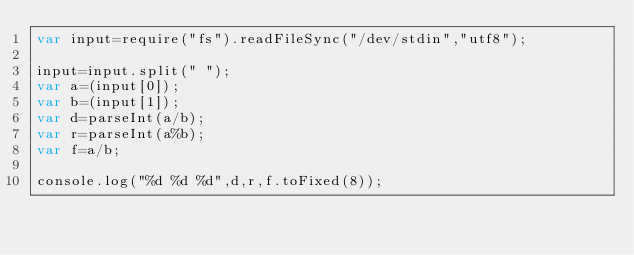<code> <loc_0><loc_0><loc_500><loc_500><_JavaScript_>var input=require("fs").readFileSync("/dev/stdin","utf8");

input=input.split(" ");
var a=(input[0]);
var b=(input[1]);
var d=parseInt(a/b);
var r=parseInt(a%b);
var f=a/b;

console.log("%d %d %d",d,r,f.toFixed(8));
</code> 